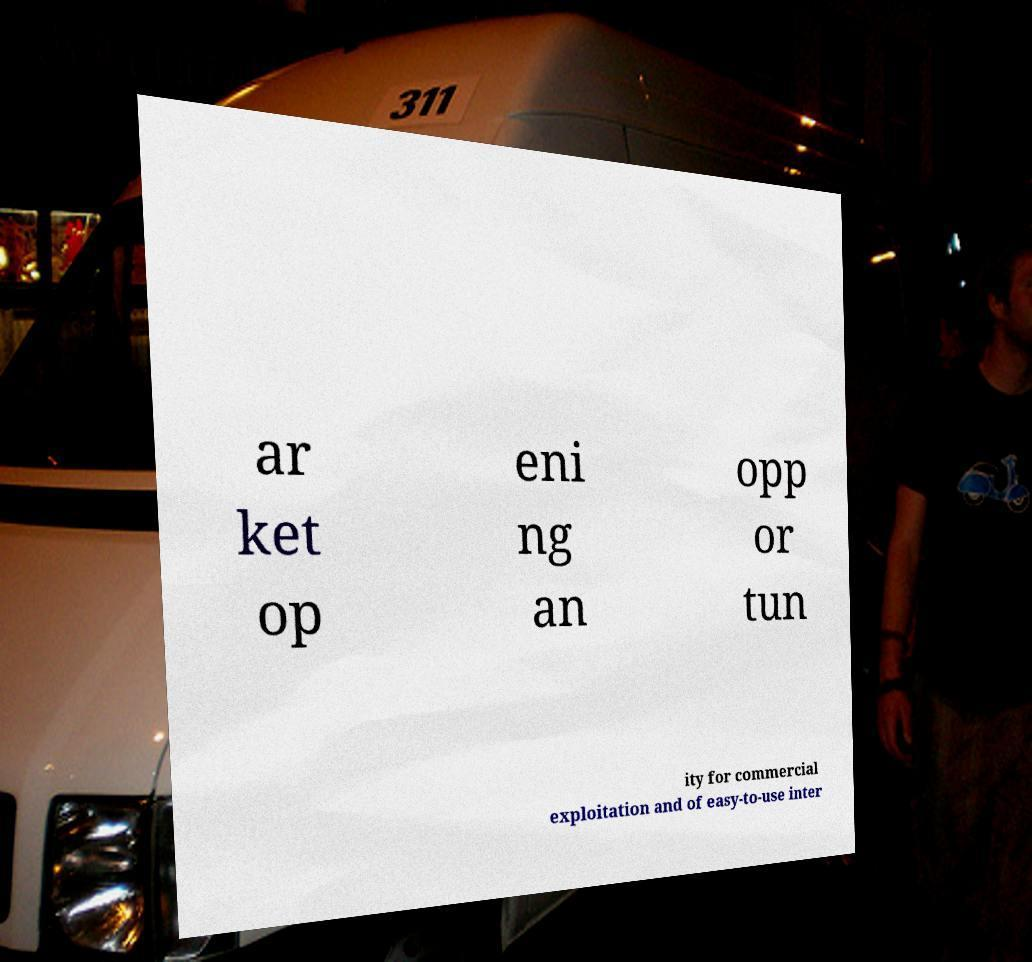There's text embedded in this image that I need extracted. Can you transcribe it verbatim? ar ket op eni ng an opp or tun ity for commercial exploitation and of easy-to-use inter 